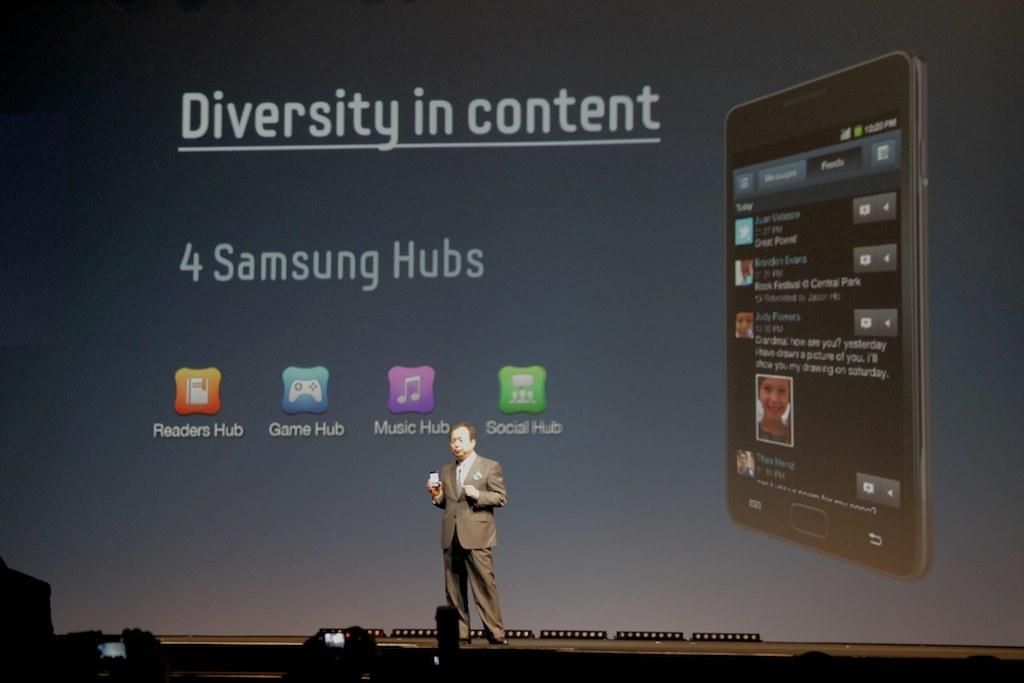Provide a one-sentence caption for the provided image. a man standing in front of a huge projection screen that says 'diversity in content' on it. 